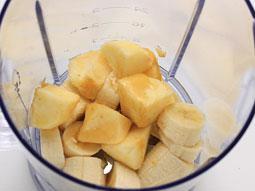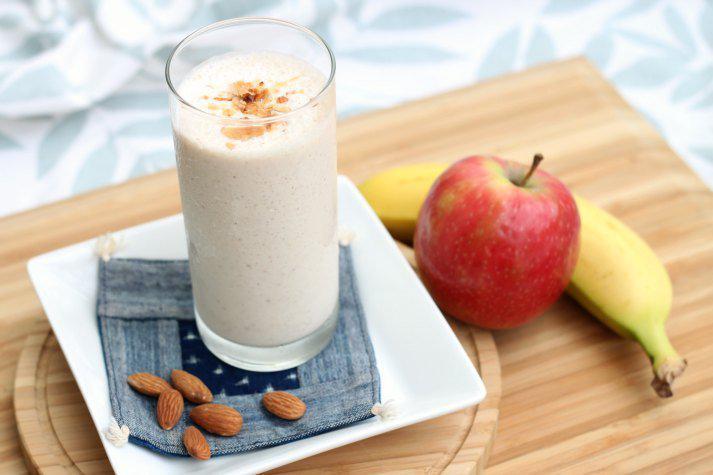The first image is the image on the left, the second image is the image on the right. Considering the images on both sides, is "A glass containing a straw in a creamy beverage is in front of unpeeled bananas." valid? Answer yes or no. No. The first image is the image on the left, the second image is the image on the right. Given the left and right images, does the statement "In one image, a creamy drink is served with a garnish in a clear glass that is sitting near at least two unpeeled pieces of fruit." hold true? Answer yes or no. Yes. 